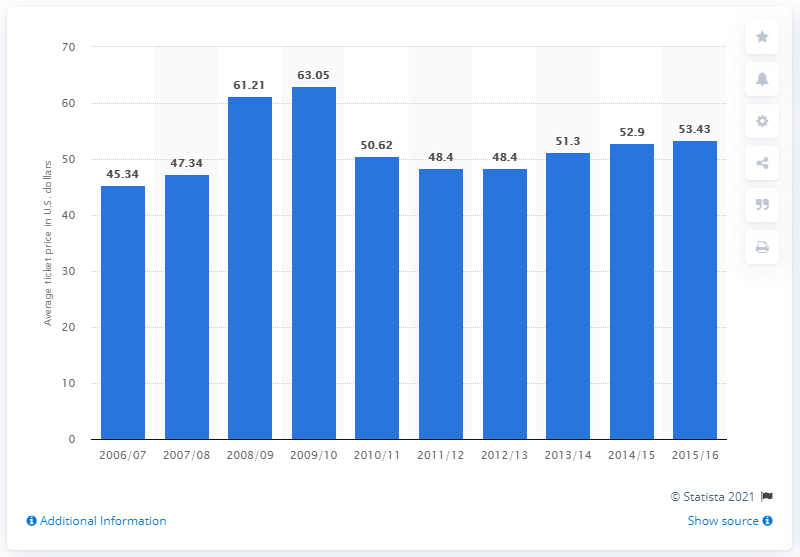Specify some key components in this picture. The average ticket price in the 2006/07 season was 45.34. 